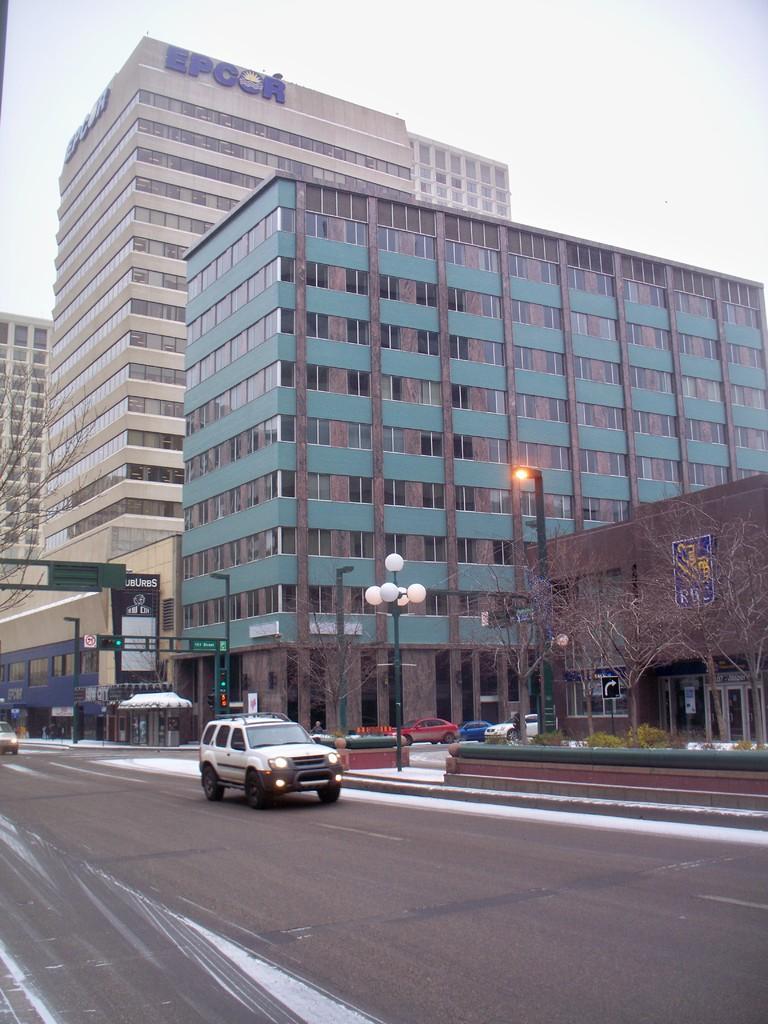How would you summarize this image in a sentence or two? In this image we can see a road. On the road there are vehicles. On the side of the road there is a light pole. Also there are trees and buildings. And there are name boards. And also there are light poles. In the background there is sky. 